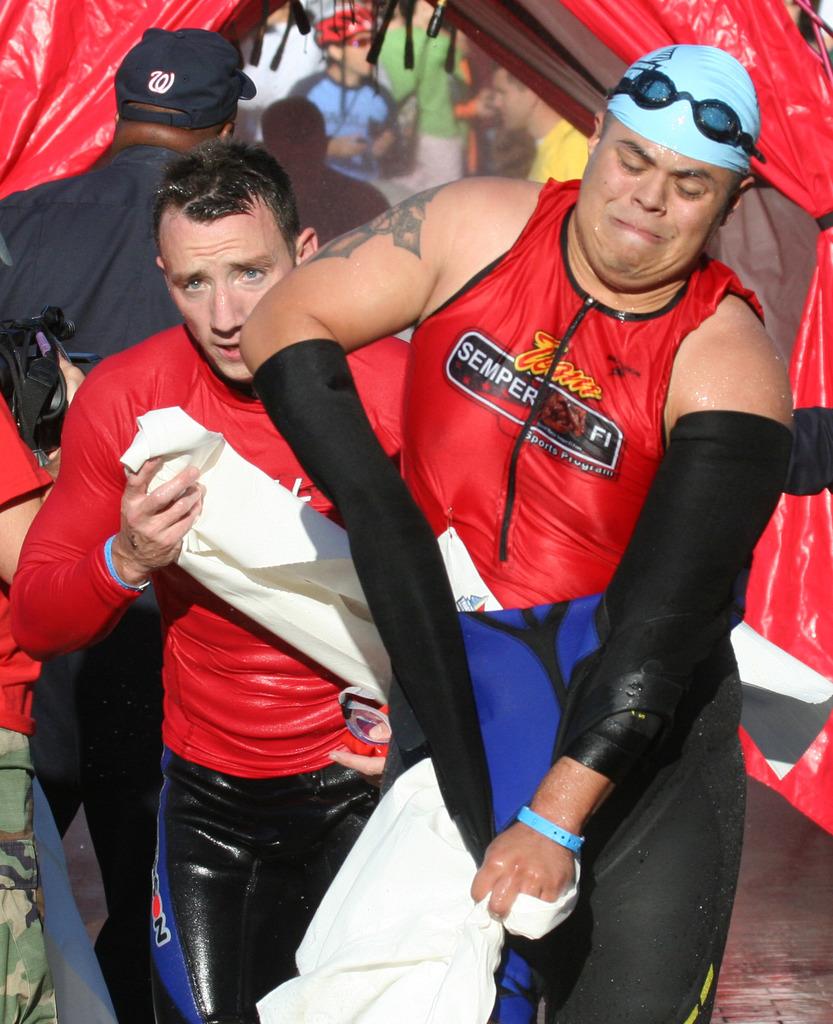What letter is on the black hat on the top left?
Ensure brevity in your answer.  W. 